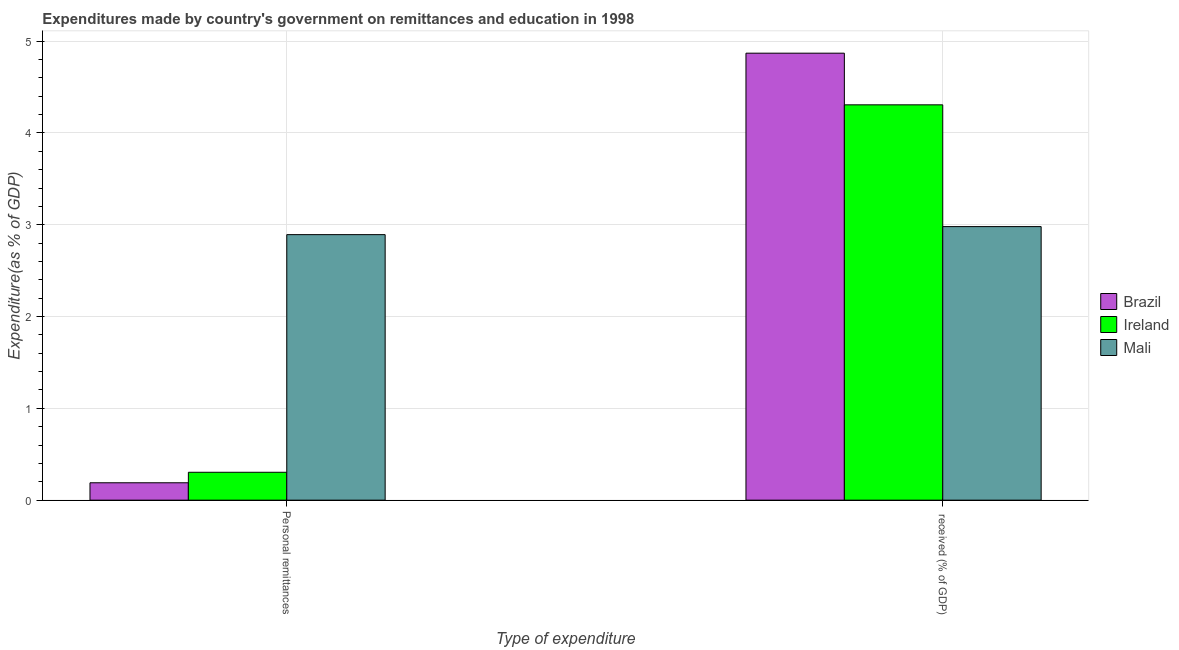How many different coloured bars are there?
Your response must be concise. 3. How many groups of bars are there?
Make the answer very short. 2. How many bars are there on the 2nd tick from the right?
Provide a short and direct response. 3. What is the label of the 2nd group of bars from the left?
Offer a terse response.  received (% of GDP). What is the expenditure in education in Ireland?
Provide a succinct answer. 4.31. Across all countries, what is the maximum expenditure in education?
Keep it short and to the point. 4.87. Across all countries, what is the minimum expenditure in personal remittances?
Your response must be concise. 0.19. In which country was the expenditure in education maximum?
Provide a succinct answer. Brazil. In which country was the expenditure in education minimum?
Make the answer very short. Mali. What is the total expenditure in personal remittances in the graph?
Your answer should be compact. 3.39. What is the difference between the expenditure in education in Brazil and that in Ireland?
Your answer should be very brief. 0.56. What is the difference between the expenditure in personal remittances in Ireland and the expenditure in education in Mali?
Offer a very short reply. -2.68. What is the average expenditure in personal remittances per country?
Offer a very short reply. 1.13. What is the difference between the expenditure in education and expenditure in personal remittances in Mali?
Offer a terse response. 0.09. In how many countries, is the expenditure in education greater than 2.2 %?
Offer a terse response. 3. What is the ratio of the expenditure in education in Ireland to that in Mali?
Your answer should be very brief. 1.45. Is the expenditure in personal remittances in Mali less than that in Ireland?
Your answer should be very brief. No. What does the 1st bar from the right in  received (% of GDP) represents?
Your response must be concise. Mali. How many bars are there?
Your response must be concise. 6. What is the difference between two consecutive major ticks on the Y-axis?
Offer a terse response. 1. Are the values on the major ticks of Y-axis written in scientific E-notation?
Give a very brief answer. No. Does the graph contain grids?
Ensure brevity in your answer.  Yes. How many legend labels are there?
Keep it short and to the point. 3. How are the legend labels stacked?
Make the answer very short. Vertical. What is the title of the graph?
Provide a succinct answer. Expenditures made by country's government on remittances and education in 1998. What is the label or title of the X-axis?
Keep it short and to the point. Type of expenditure. What is the label or title of the Y-axis?
Your response must be concise. Expenditure(as % of GDP). What is the Expenditure(as % of GDP) of Brazil in Personal remittances?
Give a very brief answer. 0.19. What is the Expenditure(as % of GDP) in Ireland in Personal remittances?
Give a very brief answer. 0.3. What is the Expenditure(as % of GDP) of Mali in Personal remittances?
Your answer should be very brief. 2.89. What is the Expenditure(as % of GDP) in Brazil in  received (% of GDP)?
Your answer should be compact. 4.87. What is the Expenditure(as % of GDP) in Ireland in  received (% of GDP)?
Keep it short and to the point. 4.31. What is the Expenditure(as % of GDP) in Mali in  received (% of GDP)?
Offer a very short reply. 2.98. Across all Type of expenditure, what is the maximum Expenditure(as % of GDP) of Brazil?
Your answer should be compact. 4.87. Across all Type of expenditure, what is the maximum Expenditure(as % of GDP) of Ireland?
Your answer should be compact. 4.31. Across all Type of expenditure, what is the maximum Expenditure(as % of GDP) of Mali?
Give a very brief answer. 2.98. Across all Type of expenditure, what is the minimum Expenditure(as % of GDP) in Brazil?
Give a very brief answer. 0.19. Across all Type of expenditure, what is the minimum Expenditure(as % of GDP) of Ireland?
Your answer should be compact. 0.3. Across all Type of expenditure, what is the minimum Expenditure(as % of GDP) of Mali?
Provide a succinct answer. 2.89. What is the total Expenditure(as % of GDP) in Brazil in the graph?
Provide a succinct answer. 5.06. What is the total Expenditure(as % of GDP) in Ireland in the graph?
Your answer should be very brief. 4.61. What is the total Expenditure(as % of GDP) of Mali in the graph?
Provide a short and direct response. 5.87. What is the difference between the Expenditure(as % of GDP) of Brazil in Personal remittances and that in  received (% of GDP)?
Give a very brief answer. -4.68. What is the difference between the Expenditure(as % of GDP) of Ireland in Personal remittances and that in  received (% of GDP)?
Provide a short and direct response. -4. What is the difference between the Expenditure(as % of GDP) in Mali in Personal remittances and that in  received (% of GDP)?
Your answer should be very brief. -0.09. What is the difference between the Expenditure(as % of GDP) of Brazil in Personal remittances and the Expenditure(as % of GDP) of Ireland in  received (% of GDP)?
Provide a short and direct response. -4.12. What is the difference between the Expenditure(as % of GDP) of Brazil in Personal remittances and the Expenditure(as % of GDP) of Mali in  received (% of GDP)?
Keep it short and to the point. -2.79. What is the difference between the Expenditure(as % of GDP) of Ireland in Personal remittances and the Expenditure(as % of GDP) of Mali in  received (% of GDP)?
Ensure brevity in your answer.  -2.68. What is the average Expenditure(as % of GDP) in Brazil per Type of expenditure?
Keep it short and to the point. 2.53. What is the average Expenditure(as % of GDP) in Ireland per Type of expenditure?
Make the answer very short. 2.31. What is the average Expenditure(as % of GDP) of Mali per Type of expenditure?
Your answer should be compact. 2.94. What is the difference between the Expenditure(as % of GDP) of Brazil and Expenditure(as % of GDP) of Ireland in Personal remittances?
Ensure brevity in your answer.  -0.11. What is the difference between the Expenditure(as % of GDP) of Brazil and Expenditure(as % of GDP) of Mali in Personal remittances?
Provide a short and direct response. -2.7. What is the difference between the Expenditure(as % of GDP) of Ireland and Expenditure(as % of GDP) of Mali in Personal remittances?
Your answer should be very brief. -2.59. What is the difference between the Expenditure(as % of GDP) of Brazil and Expenditure(as % of GDP) of Ireland in  received (% of GDP)?
Offer a very short reply. 0.56. What is the difference between the Expenditure(as % of GDP) of Brazil and Expenditure(as % of GDP) of Mali in  received (% of GDP)?
Provide a succinct answer. 1.89. What is the difference between the Expenditure(as % of GDP) of Ireland and Expenditure(as % of GDP) of Mali in  received (% of GDP)?
Offer a terse response. 1.33. What is the ratio of the Expenditure(as % of GDP) in Brazil in Personal remittances to that in  received (% of GDP)?
Make the answer very short. 0.04. What is the ratio of the Expenditure(as % of GDP) of Ireland in Personal remittances to that in  received (% of GDP)?
Your answer should be very brief. 0.07. What is the ratio of the Expenditure(as % of GDP) of Mali in Personal remittances to that in  received (% of GDP)?
Your answer should be compact. 0.97. What is the difference between the highest and the second highest Expenditure(as % of GDP) in Brazil?
Make the answer very short. 4.68. What is the difference between the highest and the second highest Expenditure(as % of GDP) of Ireland?
Ensure brevity in your answer.  4. What is the difference between the highest and the second highest Expenditure(as % of GDP) of Mali?
Offer a terse response. 0.09. What is the difference between the highest and the lowest Expenditure(as % of GDP) of Brazil?
Provide a short and direct response. 4.68. What is the difference between the highest and the lowest Expenditure(as % of GDP) in Ireland?
Ensure brevity in your answer.  4. What is the difference between the highest and the lowest Expenditure(as % of GDP) in Mali?
Your answer should be compact. 0.09. 